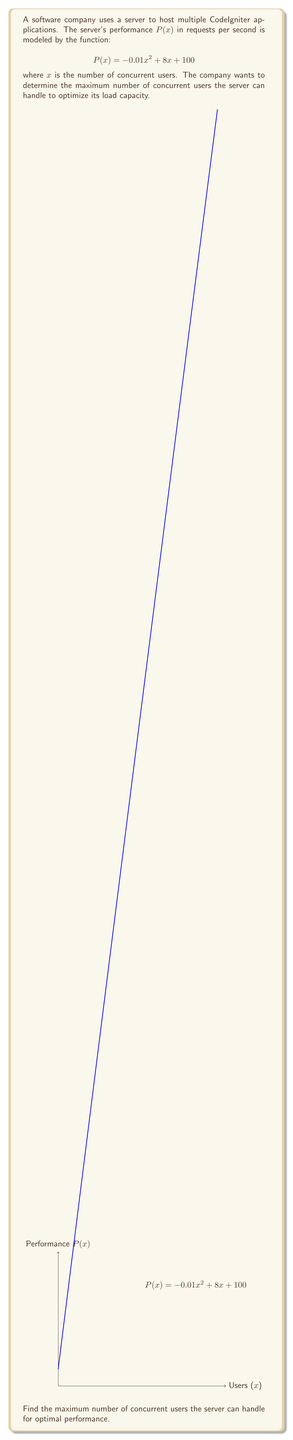Solve this math problem. To find the maximum number of concurrent users, we need to find the x-coordinate of the vertex of the parabola described by $P(x)$. This can be done using the following steps:

1) The general form of a quadratic function is $f(x) = ax^2 + bx + c$. In this case:
   $a = -0.01$, $b = 8$, and $c = 100$

2) For a quadratic function, the x-coordinate of the vertex is given by the formula:
   $$x = -\frac{b}{2a}$$

3) Substituting our values:
   $$x = -\frac{8}{2(-0.01)} = -\frac{8}{-0.02} = 400$$

4) To verify this is a maximum (not a minimum), we can check that $a < 0$, which it is.

5) We can also calculate the maximum performance:
   $P(400) = -0.01(400)^2 + 8(400) + 100 = -1600 + 3200 + 100 = 1700$ requests per second

Therefore, the server can handle a maximum of 400 concurrent users for optimal performance.
Answer: 400 users 